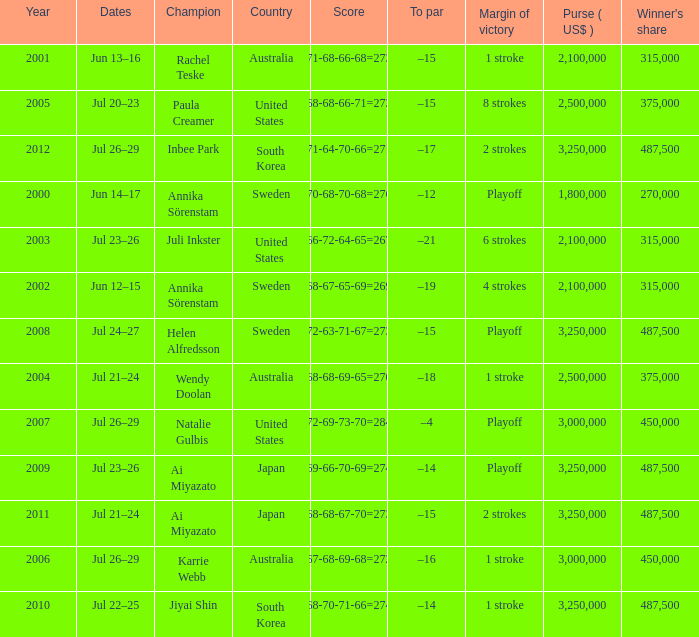Which Country has a Score of 70-68-70-68=276? Sweden. 